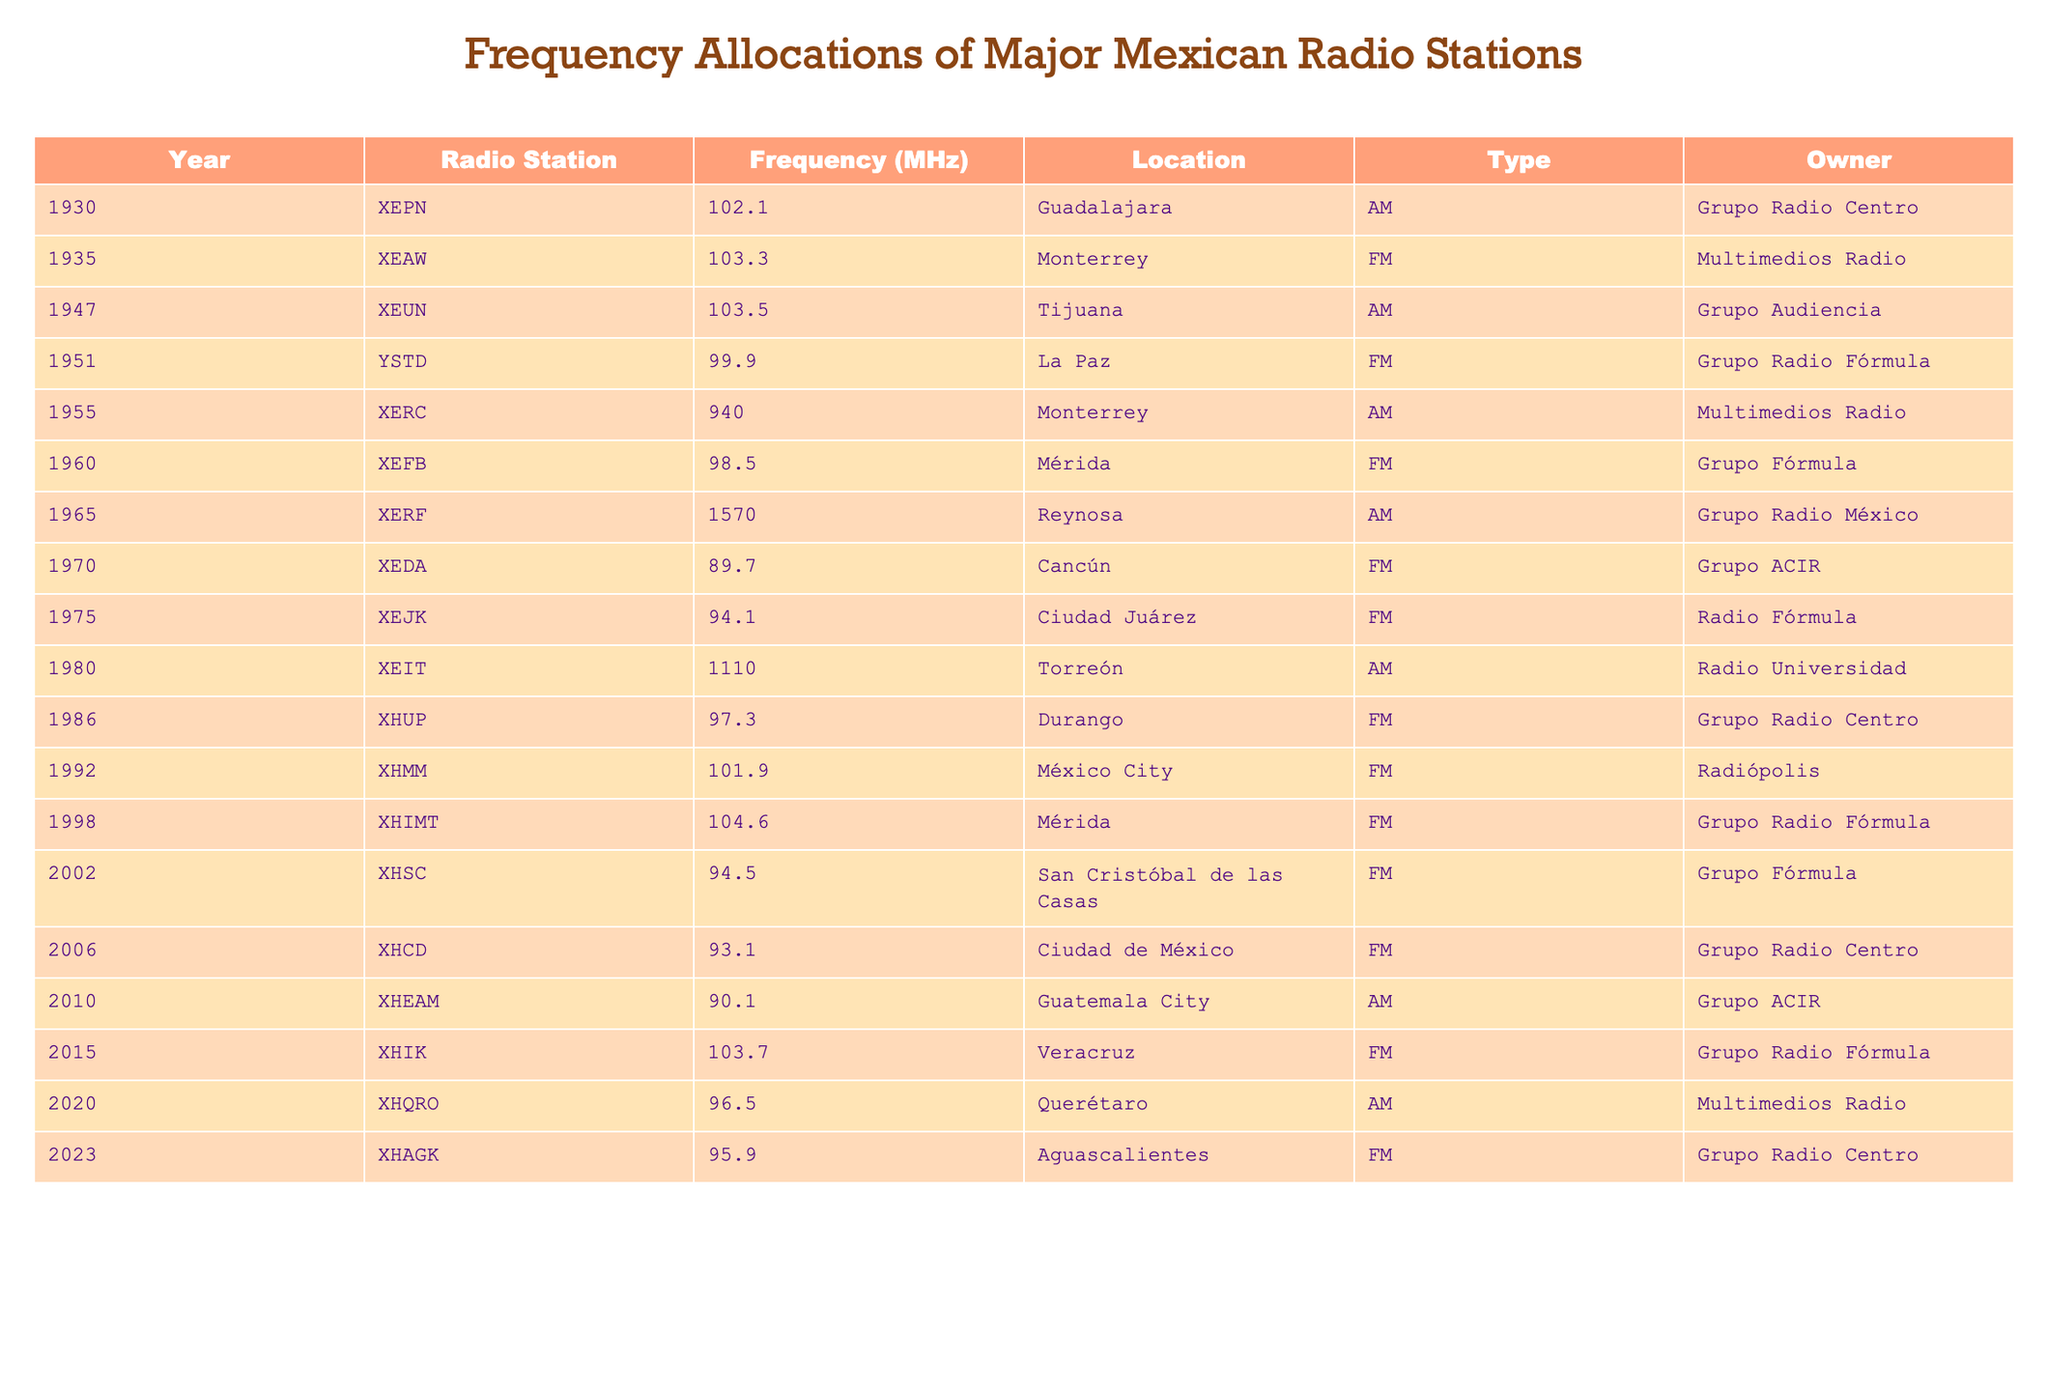What year did XEIT start broadcasting? According to the table, XEIT began broadcasting in the year 1980.
Answer: 1980 Which radio station has the highest frequency? Looking at the frequencies listed, the highest frequency is 1570 MHz, which belongs to XERF.
Answer: XERF How many FM stations were established before 1960? From the table, there are three FM stations before 1960: XEAW (1935), YSTD (1951), and XEFB (1960).
Answer: 3 What is the frequency of the radio station located in Tijuana? The station located in Tijuana is XEUN, which broadcasts at a frequency of 103.5 MHz.
Answer: 103.5 MHz What is the average frequency of all radio stations listed in the table? The frequencies are 102.1, 103.3, 103.5, 99.9, 940, 98.5, 1570, 89.7, 94.1, 1110, 97.3, 101.9, 104.6, 94.5, 93.1, 90.1, 103.7, 96.5, and 95.9. Summing these gives 2979.4 MHz. There are 18 stations, so the average is 2979.4 / 18 = 165.52 MHz.
Answer: 165.52 MHz Is XHQRO an FM or AM station? The table indicates that XHQRO, located in Querétaro, is classified as an AM station.
Answer: AM Which radio station was established last and where is it located? According to the table, the last radio station established is XHAGK in Aguascalientes in the year 2023.
Answer: XHAGK, Aguascalientes How many radio stations owned by Grupo Radio Centro are listed in the table? The table shows that there are four stations owned by Grupo Radio Centro: XEPN, XHUP, XHCD, and XHAGK.
Answer: 4 Which radio station broadcasts on 94.1 MHz? The station that broadcasts on 94.1 MHz is XEJK, located in Ciudad Juárez.
Answer: XEJK What are the locations of the FM stations established after 2000? The FM stations established after 2000 are XHIMT (Mérida, 1998), XHSC (San Cristóbal de las Casas, 2002), XHIK (Veracruz, 2015), and XHAGK (Aguascalientes, 2023). Their locations are Mérida, San Cristóbal de las Casas, Veracruz, and Aguascalientes.
Answer: Mérida, San Cristóbal de las Casas, Veracruz, Aguascalientes What percentage of the stations listed are owned by Grupo Radio Fórmula? There are 4 stations owned by Grupo Radio Fórmula (YSTD, XEJK, XHIMT, XHIK), and there are 18 total stations. The percentage is (4/18) * 100, which equals approximately 22.22%.
Answer: 22.22% 